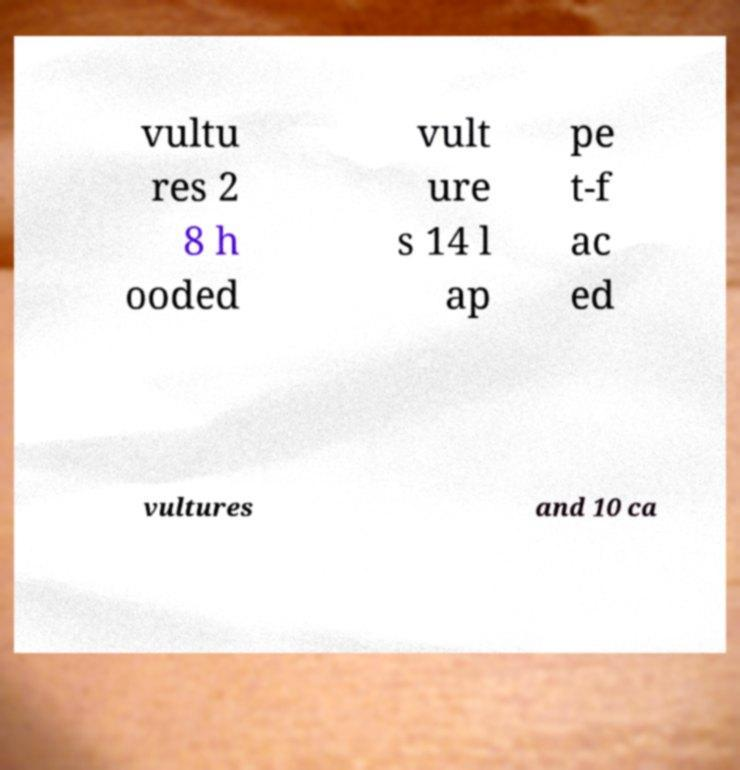For documentation purposes, I need the text within this image transcribed. Could you provide that? vultu res 2 8 h ooded vult ure s 14 l ap pe t-f ac ed vultures and 10 ca 